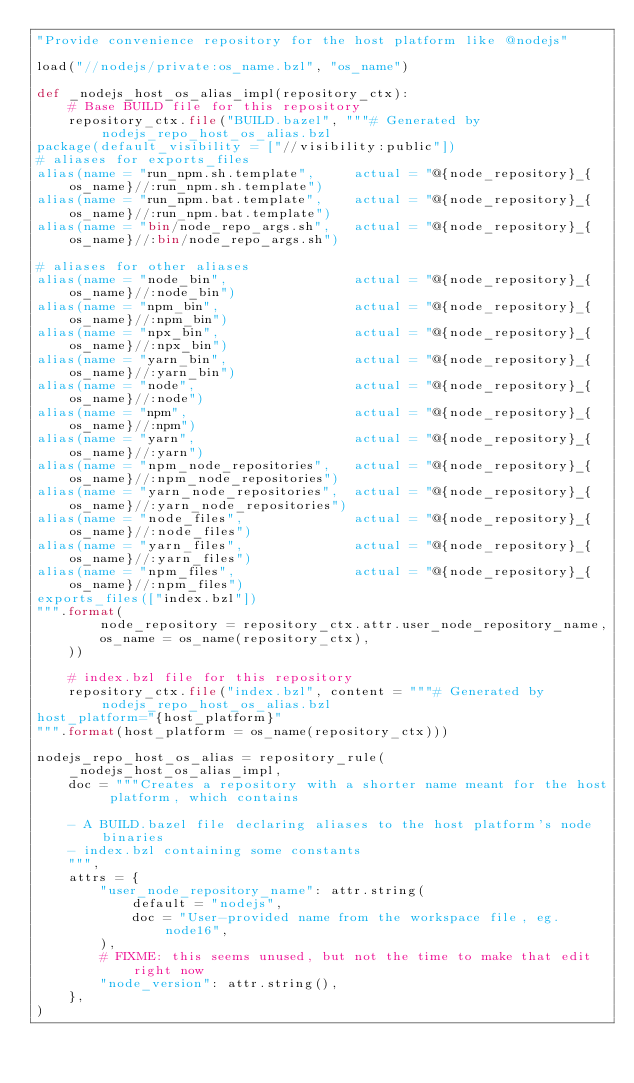<code> <loc_0><loc_0><loc_500><loc_500><_Python_>"Provide convenience repository for the host platform like @nodejs"

load("//nodejs/private:os_name.bzl", "os_name")

def _nodejs_host_os_alias_impl(repository_ctx):
    # Base BUILD file for this repository
    repository_ctx.file("BUILD.bazel", """# Generated by nodejs_repo_host_os_alias.bzl
package(default_visibility = ["//visibility:public"])
# aliases for exports_files
alias(name = "run_npm.sh.template",     actual = "@{node_repository}_{os_name}//:run_npm.sh.template")
alias(name = "run_npm.bat.template",    actual = "@{node_repository}_{os_name}//:run_npm.bat.template")
alias(name = "bin/node_repo_args.sh",   actual = "@{node_repository}_{os_name}//:bin/node_repo_args.sh")

# aliases for other aliases
alias(name = "node_bin",                actual = "@{node_repository}_{os_name}//:node_bin")
alias(name = "npm_bin",                 actual = "@{node_repository}_{os_name}//:npm_bin")
alias(name = "npx_bin",                 actual = "@{node_repository}_{os_name}//:npx_bin")
alias(name = "yarn_bin",                actual = "@{node_repository}_{os_name}//:yarn_bin")
alias(name = "node",                    actual = "@{node_repository}_{os_name}//:node")
alias(name = "npm",                     actual = "@{node_repository}_{os_name}//:npm")
alias(name = "yarn",                    actual = "@{node_repository}_{os_name}//:yarn")
alias(name = "npm_node_repositories",   actual = "@{node_repository}_{os_name}//:npm_node_repositories")
alias(name = "yarn_node_repositories",  actual = "@{node_repository}_{os_name}//:yarn_node_repositories")
alias(name = "node_files",              actual = "@{node_repository}_{os_name}//:node_files")
alias(name = "yarn_files",              actual = "@{node_repository}_{os_name}//:yarn_files")
alias(name = "npm_files",               actual = "@{node_repository}_{os_name}//:npm_files")
exports_files(["index.bzl"])
""".format(
        node_repository = repository_ctx.attr.user_node_repository_name,
        os_name = os_name(repository_ctx),
    ))

    # index.bzl file for this repository
    repository_ctx.file("index.bzl", content = """# Generated by nodejs_repo_host_os_alias.bzl
host_platform="{host_platform}"
""".format(host_platform = os_name(repository_ctx)))

nodejs_repo_host_os_alias = repository_rule(
    _nodejs_host_os_alias_impl,
    doc = """Creates a repository with a shorter name meant for the host platform, which contains

    - A BUILD.bazel file declaring aliases to the host platform's node binaries
    - index.bzl containing some constants
    """,
    attrs = {
        "user_node_repository_name": attr.string(
            default = "nodejs",
            doc = "User-provided name from the workspace file, eg. node16",
        ),
        # FIXME: this seems unused, but not the time to make that edit right now
        "node_version": attr.string(),
    },
)
</code> 